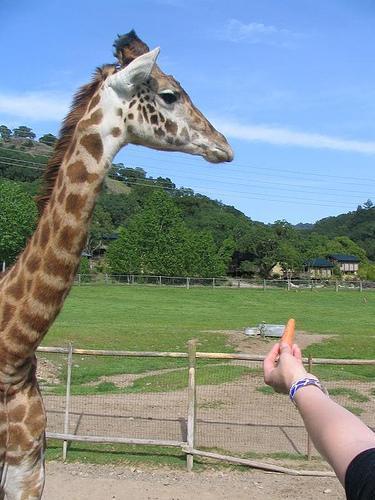How many giraffes are shown?
Give a very brief answer. 1. How many horns are visible?
Give a very brief answer. 1. How many dominos pizza logos do you see?
Give a very brief answer. 0. 